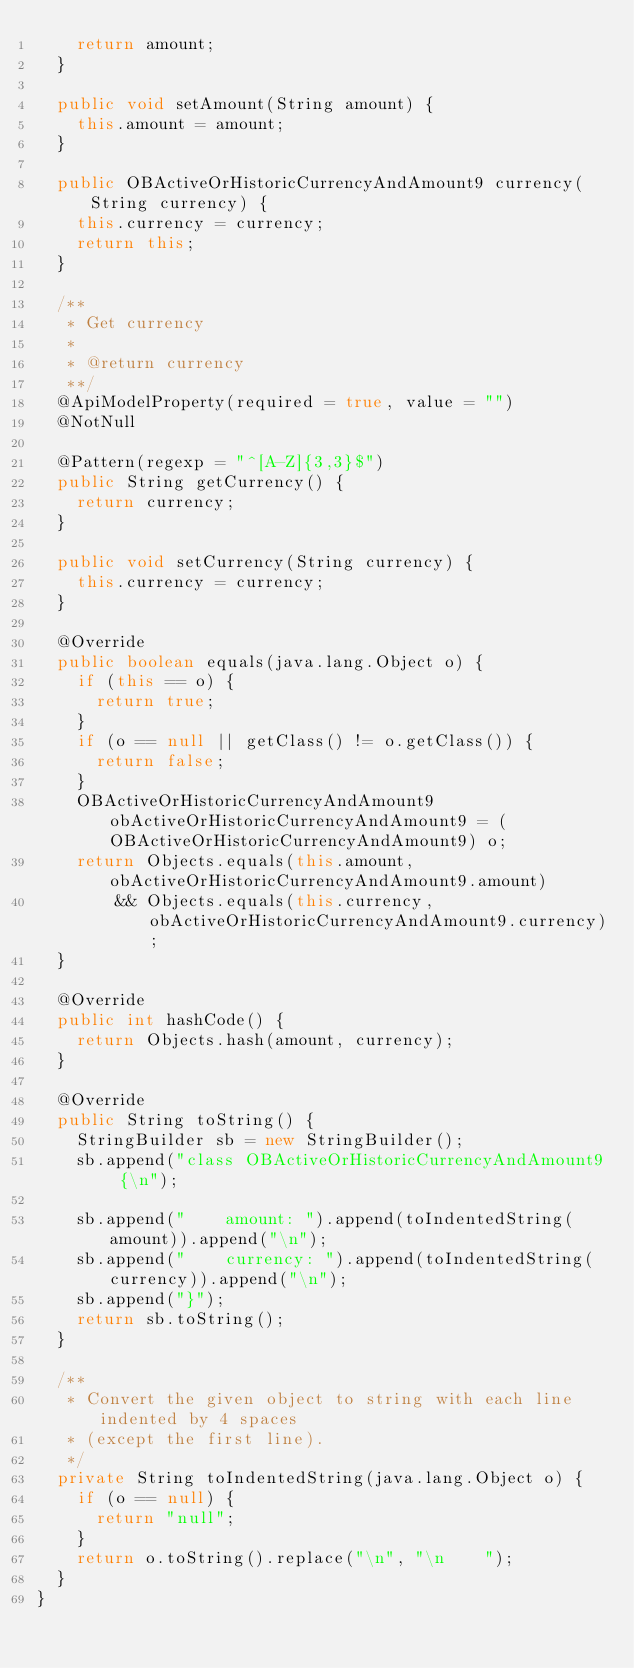<code> <loc_0><loc_0><loc_500><loc_500><_Java_>		return amount;
	}

	public void setAmount(String amount) {
		this.amount = amount;
	}

	public OBActiveOrHistoricCurrencyAndAmount9 currency(String currency) {
		this.currency = currency;
		return this;
	}

	/**
	 * Get currency
	 * 
	 * @return currency
	 **/
	@ApiModelProperty(required = true, value = "")
	@NotNull

	@Pattern(regexp = "^[A-Z]{3,3}$")
	public String getCurrency() {
		return currency;
	}

	public void setCurrency(String currency) {
		this.currency = currency;
	}

	@Override
	public boolean equals(java.lang.Object o) {
		if (this == o) {
			return true;
		}
		if (o == null || getClass() != o.getClass()) {
			return false;
		}
		OBActiveOrHistoricCurrencyAndAmount9 obActiveOrHistoricCurrencyAndAmount9 = (OBActiveOrHistoricCurrencyAndAmount9) o;
		return Objects.equals(this.amount, obActiveOrHistoricCurrencyAndAmount9.amount)
				&& Objects.equals(this.currency, obActiveOrHistoricCurrencyAndAmount9.currency);
	}

	@Override
	public int hashCode() {
		return Objects.hash(amount, currency);
	}

	@Override
	public String toString() {
		StringBuilder sb = new StringBuilder();
		sb.append("class OBActiveOrHistoricCurrencyAndAmount9 {\n");

		sb.append("    amount: ").append(toIndentedString(amount)).append("\n");
		sb.append("    currency: ").append(toIndentedString(currency)).append("\n");
		sb.append("}");
		return sb.toString();
	}

	/**
	 * Convert the given object to string with each line indented by 4 spaces
	 * (except the first line).
	 */
	private String toIndentedString(java.lang.Object o) {
		if (o == null) {
			return "null";
		}
		return o.toString().replace("\n", "\n    ");
	}
}
</code> 